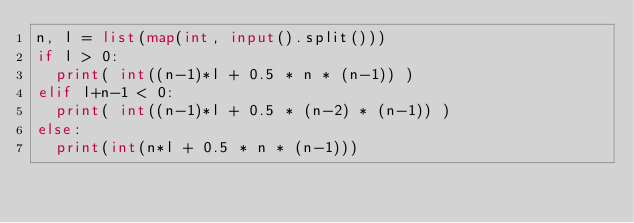<code> <loc_0><loc_0><loc_500><loc_500><_Python_>n, l = list(map(int, input().split()))
if l > 0:
  print( int((n-1)*l + 0.5 * n * (n-1)) )
elif l+n-1 < 0:
  print( int((n-1)*l + 0.5 * (n-2) * (n-1)) )
else:
  print(int(n*l + 0.5 * n * (n-1)))</code> 